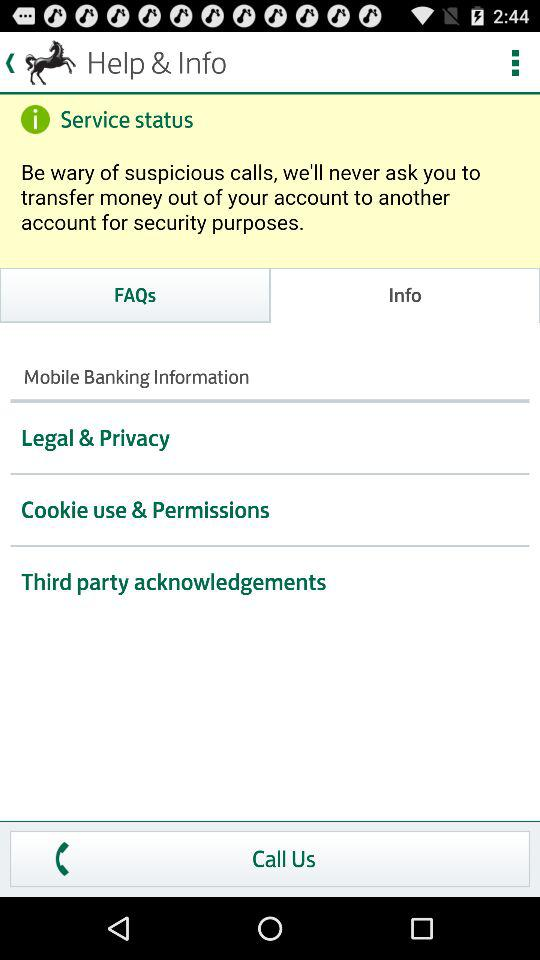Which option is selected? The selected options are "Info" and "Mobile Banking Information". 